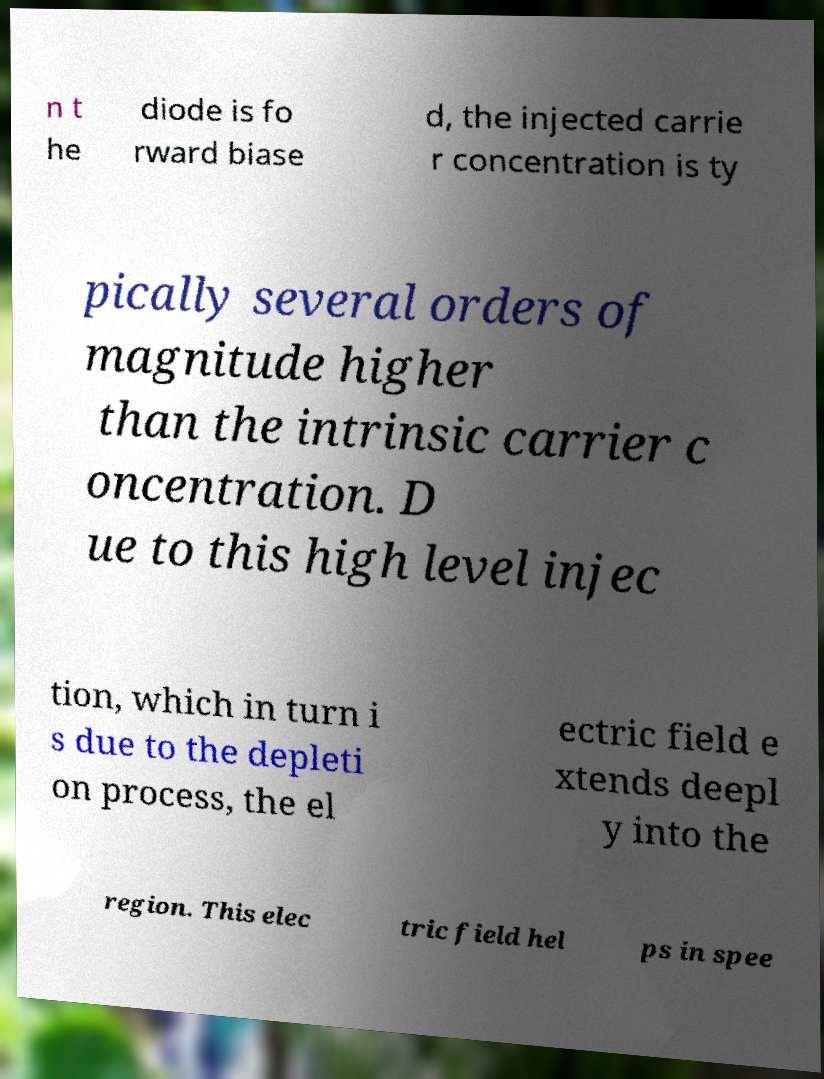I need the written content from this picture converted into text. Can you do that? n t he diode is fo rward biase d, the injected carrie r concentration is ty pically several orders of magnitude higher than the intrinsic carrier c oncentration. D ue to this high level injec tion, which in turn i s due to the depleti on process, the el ectric field e xtends deepl y into the region. This elec tric field hel ps in spee 